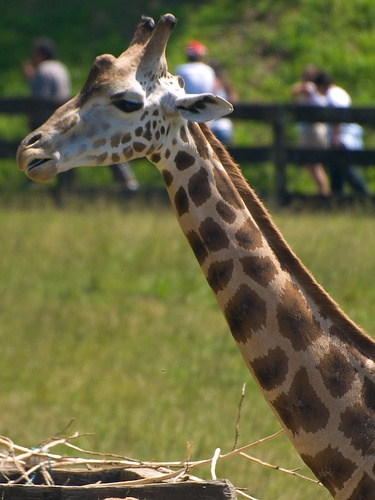Describe the objects in this image and their specific colors. I can see giraffe in black and gray tones, people in black, lavender, gray, and darkgray tones, people in black, gray, and darkgray tones, people in black, lavender, darkgray, gray, and brown tones, and people in black, gray, and darkgray tones in this image. 